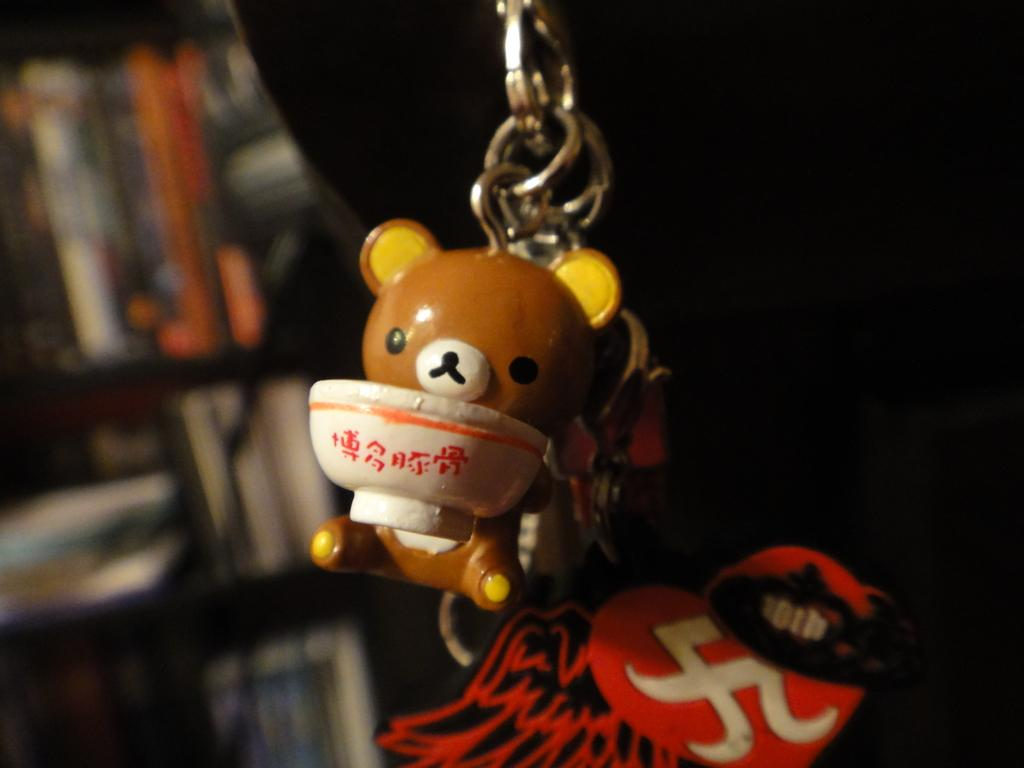What type of object is in the image that resembles a keychain? There is a toy keychain in the image. What other items can be seen in the image? There are books in the image. Where are the books located? The books are in a cupboard. How many girls are present at the meeting in the image? There is no meeting or girls present in the image; it features a toy keychain and books in a cupboard. What type of pot is visible in the image? There is no pot present in the image. 